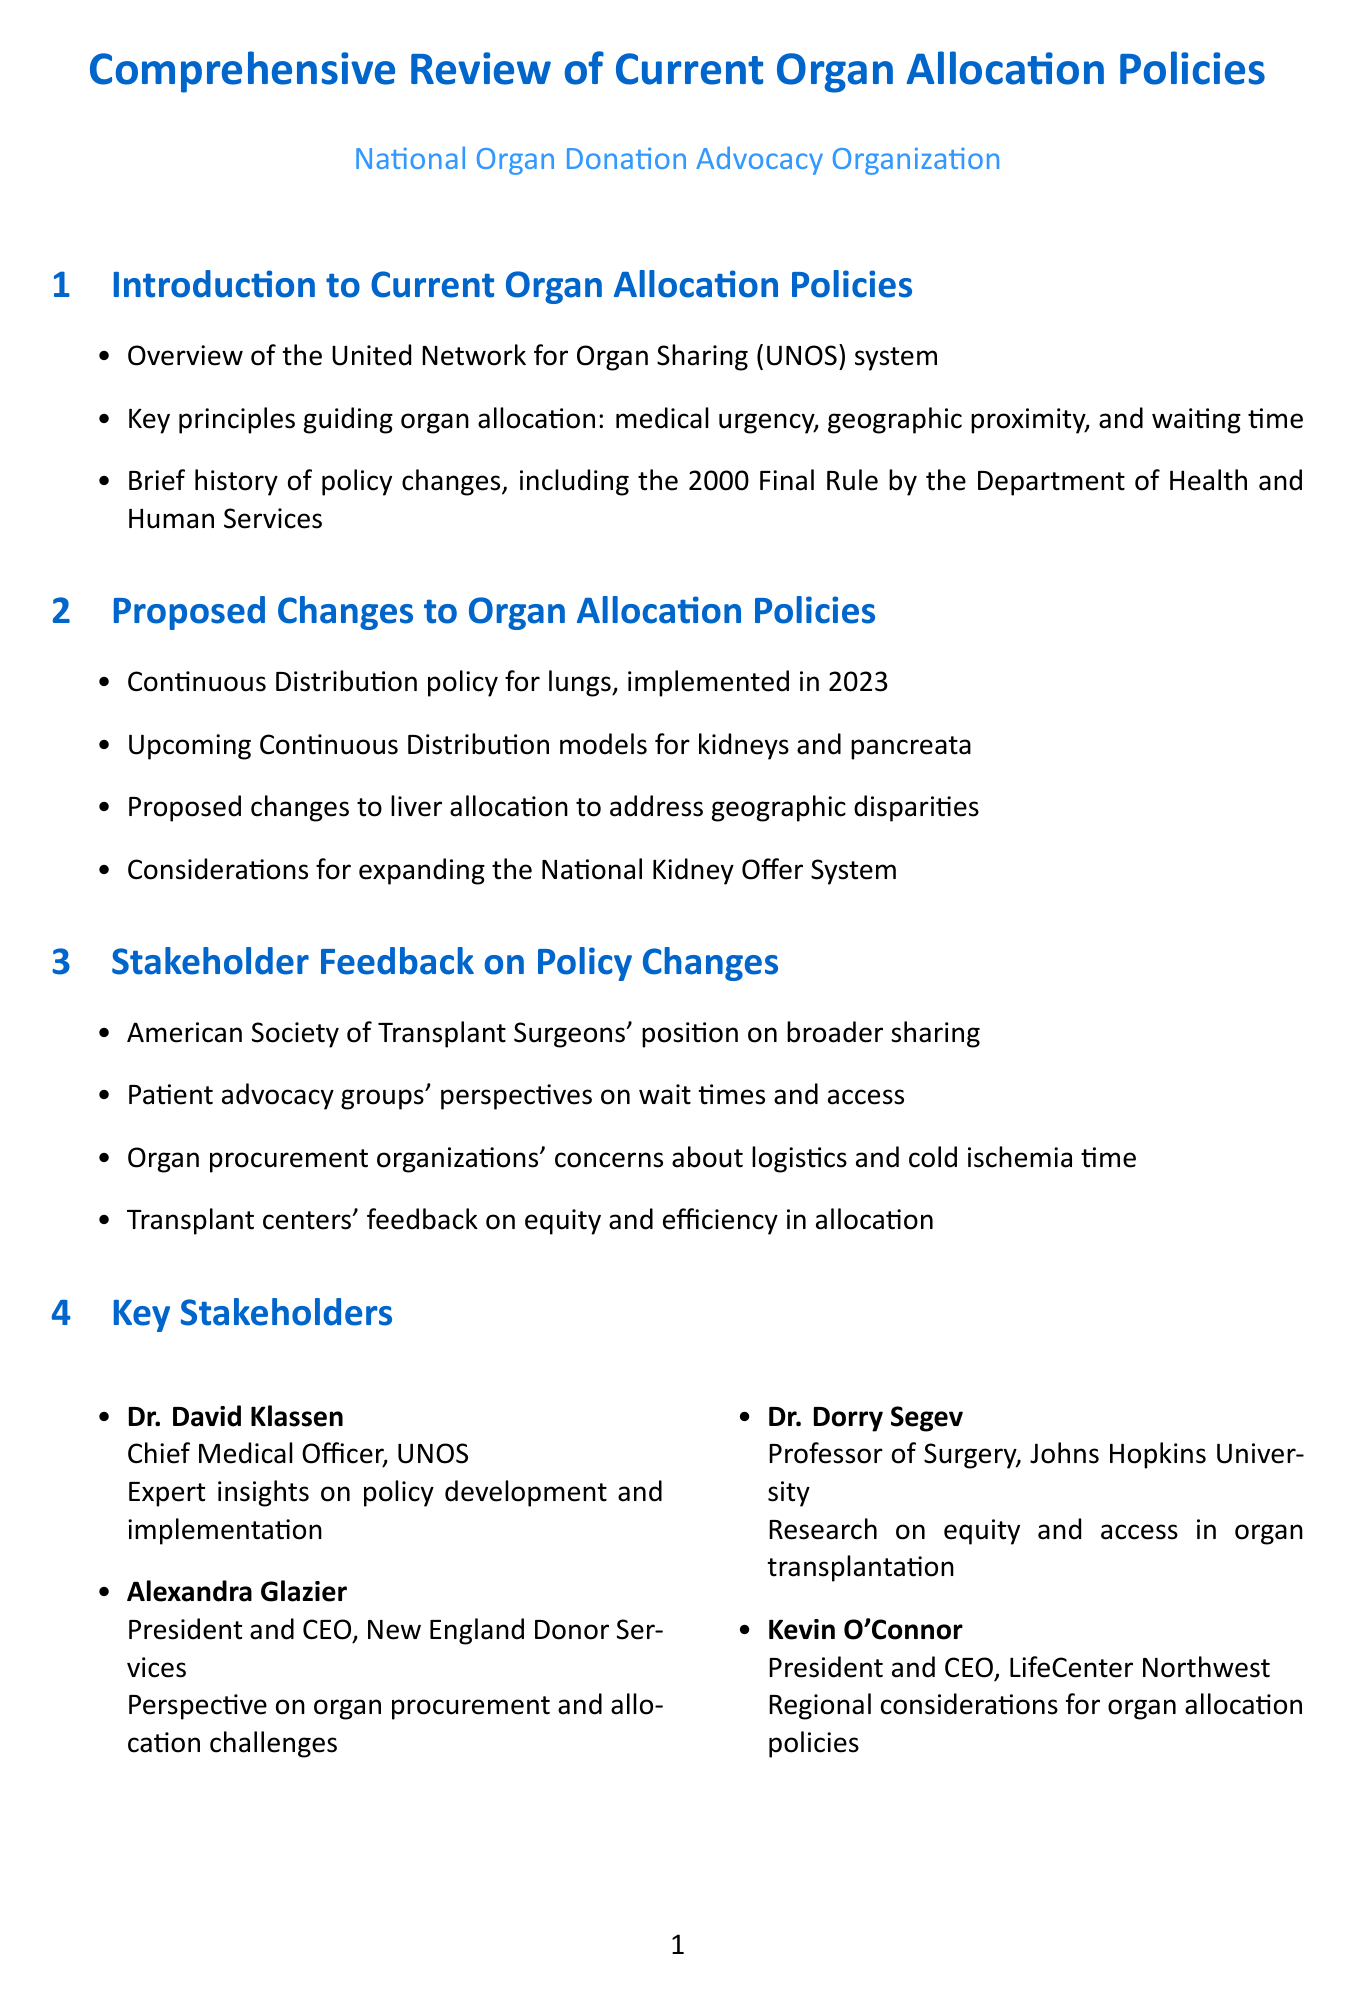What are the key principles guiding organ allocation? The key principles are medical urgency, geographic proximity, and waiting time.
Answer: medical urgency, geographic proximity, and waiting time Who implemented the Continuous Distribution policy for lungs? The document states that the Continuous Distribution policy for lungs was implemented in 2023.
Answer: 2023 Which organization expressed concern about logistics and cold ischemia time? The organ procurement organizations expressed concerns about logistics and cold ischemia time.
Answer: Organ procurement organizations What is a proposed change to liver allocation? Proposed changes to liver allocation aim to address geographic disparities.
Answer: address geographic disparities What act allowed for organ transplantation between HIV-positive individuals? The HOPE Act of 2013 allowed for organ transplantation between HIV-positive individuals.
Answer: HOPE Act of 2013 Which database provides comprehensive data on organ donation? The Organ Procurement and Transplantation Network (OPTN) Database provides comprehensive data.
Answer: Organ Procurement and Transplantation Network (OPTN) Database What technology is being developed by UNOS for matching? UNOS is developing AI and machine learning tools for matching.
Answer: AI and machine learning tools Who is the President and CEO of New England Donor Services? The President and CEO of New England Donor Services is Alexandra Glazier.
Answer: Alexandra Glazier What proposal is made for increasing organ utilization rates? The document includes recommendations for increasing organ utilization rates.
Answer: recommendations for increasing organ utilization rates 